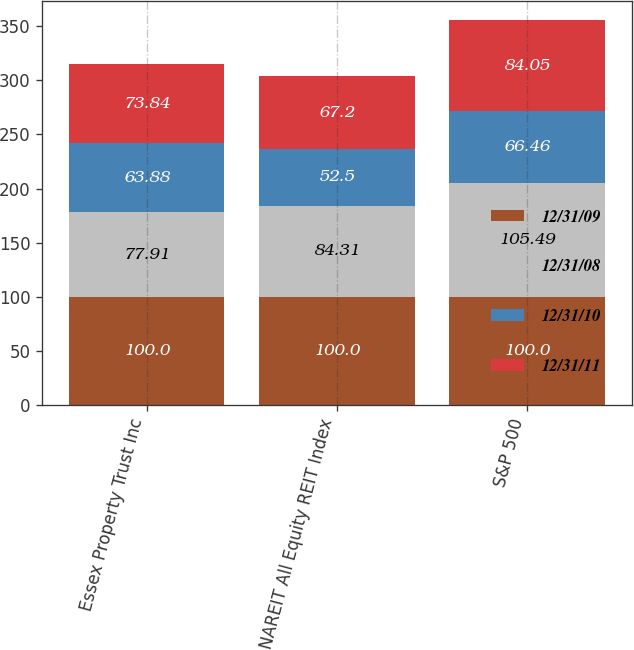Convert chart to OTSL. <chart><loc_0><loc_0><loc_500><loc_500><stacked_bar_chart><ecel><fcel>Essex Property Trust Inc<fcel>NAREIT All Equity REIT Index<fcel>S&P 500<nl><fcel>12/31/09<fcel>100<fcel>100<fcel>100<nl><fcel>12/31/08<fcel>77.91<fcel>84.31<fcel>105.49<nl><fcel>12/31/10<fcel>63.88<fcel>52.5<fcel>66.46<nl><fcel>12/31/11<fcel>73.84<fcel>67.2<fcel>84.05<nl></chart> 